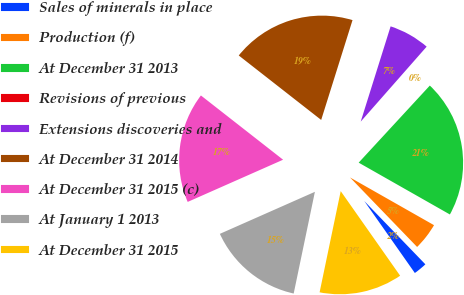Convert chart to OTSL. <chart><loc_0><loc_0><loc_500><loc_500><pie_chart><fcel>Sales of minerals in place<fcel>Production (f)<fcel>At December 31 2013<fcel>Revisions of previous<fcel>Extensions discoveries and<fcel>At December 31 2014<fcel>At December 31 2015 (c)<fcel>At January 1 2013<fcel>At December 31 2015<nl><fcel>2.47%<fcel>4.56%<fcel>21.36%<fcel>0.38%<fcel>6.64%<fcel>19.28%<fcel>17.19%<fcel>15.1%<fcel>13.02%<nl></chart> 